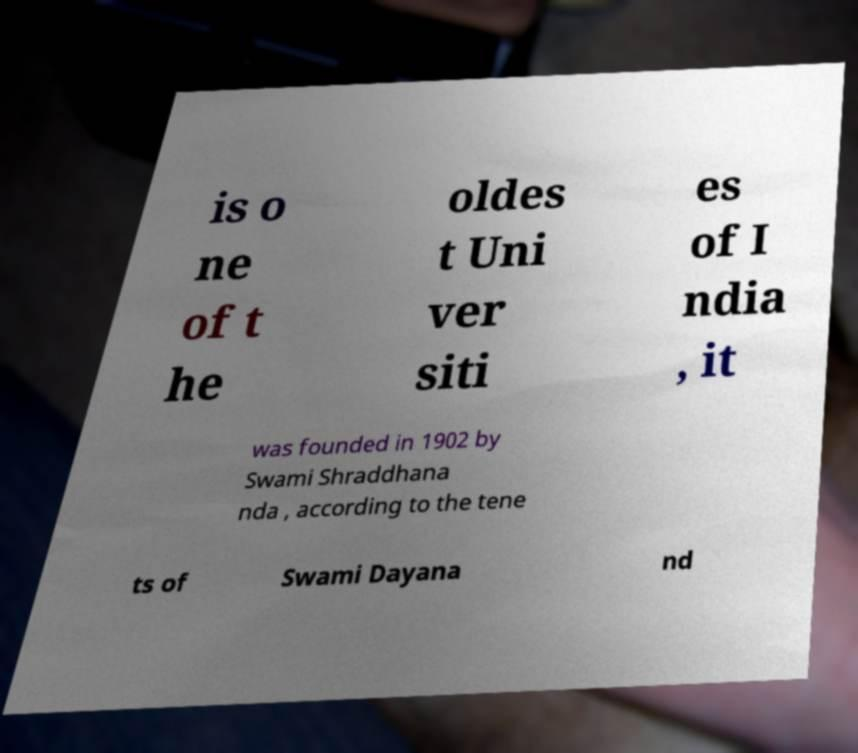Could you assist in decoding the text presented in this image and type it out clearly? is o ne of t he oldes t Uni ver siti es of I ndia , it was founded in 1902 by Swami Shraddhana nda , according to the tene ts of Swami Dayana nd 